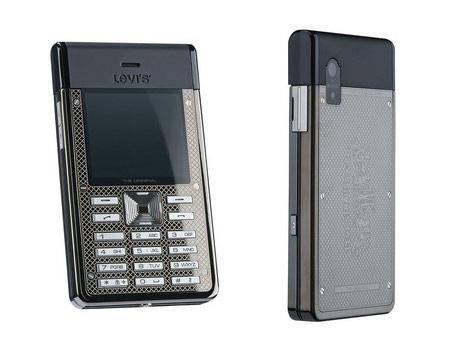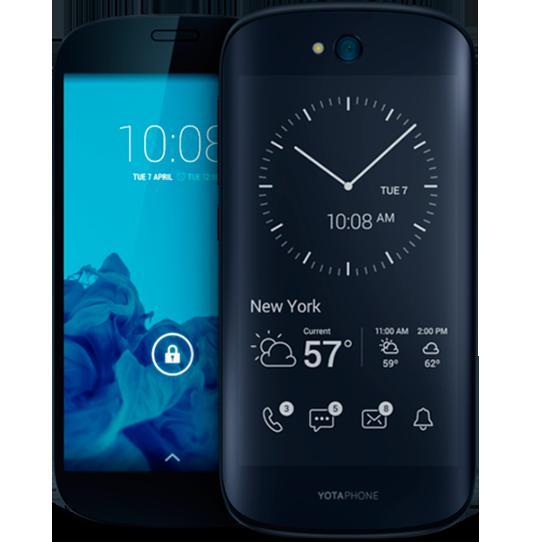The first image is the image on the left, the second image is the image on the right. Analyze the images presented: Is the assertion "One of the phones has physical keys for typing." valid? Answer yes or no. Yes. The first image is the image on the left, the second image is the image on the right. For the images displayed, is the sentence "The back of a phone is visible." factually correct? Answer yes or no. Yes. 